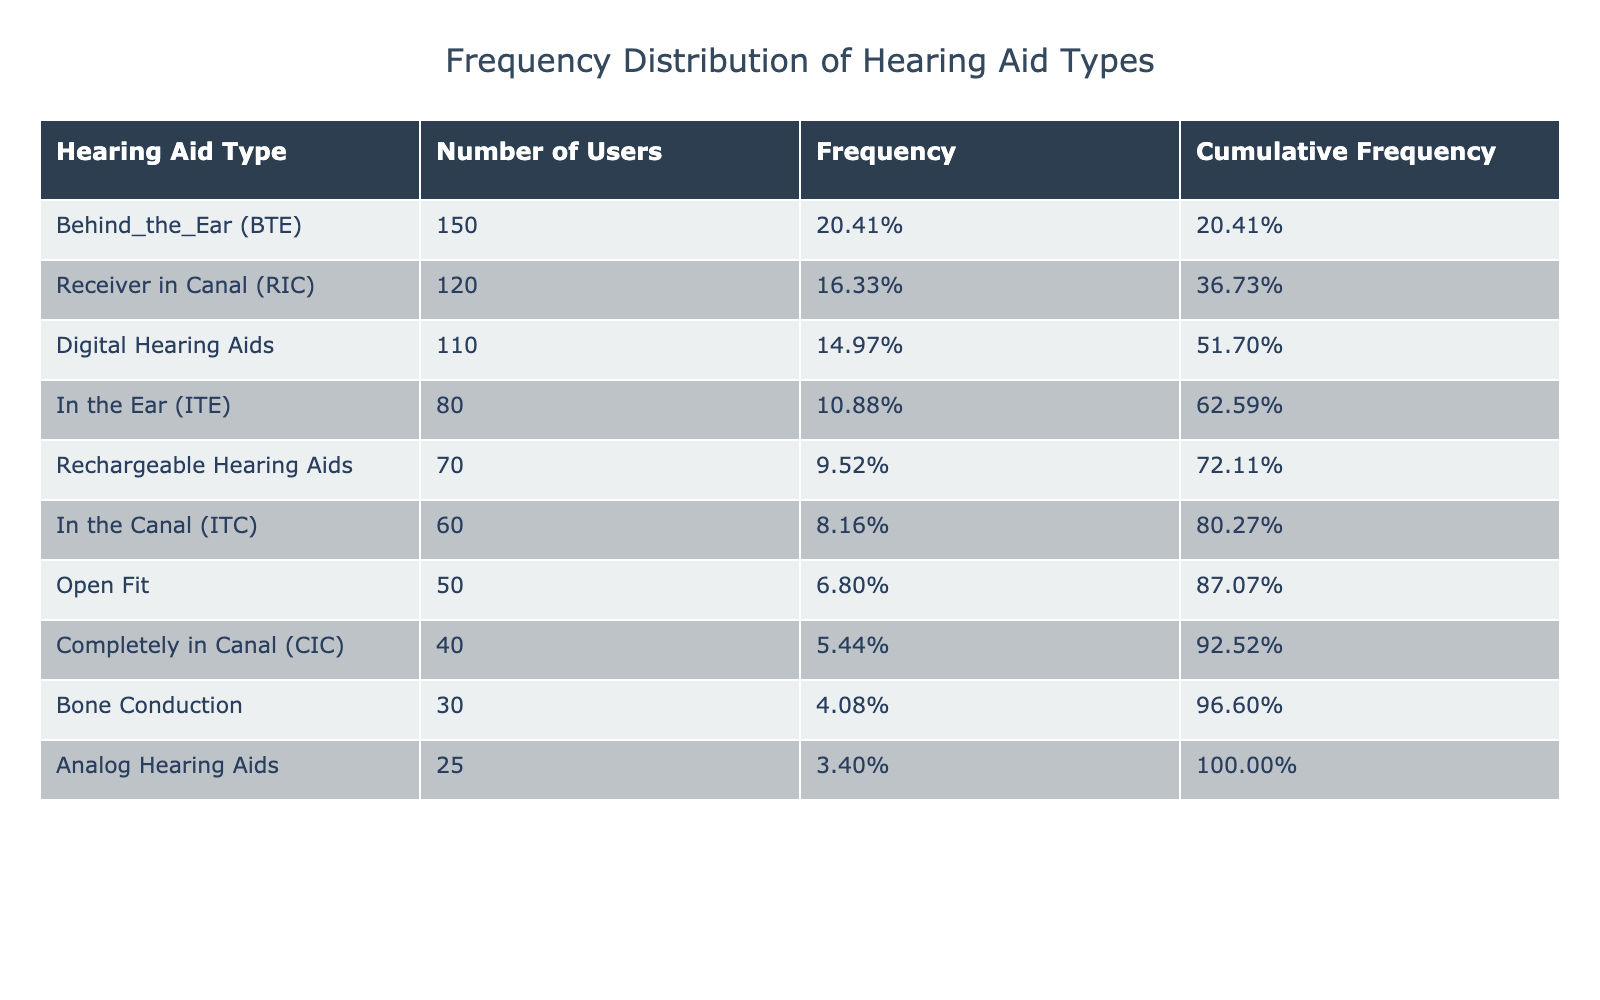What is the type of hearing aid with the highest number of users? The table shows the "Number of Users" for each hearing aid type and indicates that "Behind the Ear (BTE)" has 150 users, which is the highest figure in the table.
Answer: Behind the Ear (BTE) How many users are using Analog Hearing Aids? The table directly states that the number of users for "Analog Hearing Aids" is 25.
Answer: 25 What percentage of users use Bone Conduction aids? The total number of users across all hearing aid types is 750 (150 + 120 + 80 + 60 + 40 + 30 + 50 + 110 + 25 + 70). The number of Bone Conduction users is 30. Therefore, the percentage is (30/750) * 100 = 4%.
Answer: 4% What is the cumulative frequency of users for "In the Ear (ITE)"? To find the cumulative frequency for "In the Ear (ITE)", we add the frequencies of all types up to "In the Ear (ITE)". The frequencies are: BTE (20%), RIC (16%), ITE (10.67%). Thus, cumulative frequency = 20% + 16% + 10.67% = 46.67%.
Answer: 46.67% Are there more users of Rechargeable Hearing Aids than Completely in Canal (CIC) aids? The table shows that there are 70 users of Rechargeable Hearing Aids and 40 users of Completely in Canal (CIC) aids. Since 70 is greater than 40, the answer is yes.
Answer: Yes What is the difference in the number of users between the top two most used hearing aid types? The most used type is "Behind the Ear (BTE)" with 150 users, and the second most used is "Receiver in Canal (RIC)" with 120 users. The difference in users is calculated as 150 - 120 = 30.
Answer: 30 What fraction of the total users are using Digital Hearing Aids? The total number of users is 750, and the number of users for Digital Hearing Aids is 110. The fraction is calculated as 110/750 = 11/75 when simplified.
Answer: 11/75 Which type of hearing aids has fewer than 50 users? Looking at the table, "Completely in Canal (CIC)" with 40 users, "Bone Conduction" with 30 users, and "Analog Hearing Aids" with 25 users are the only types with fewer than 50 users.
Answer: Completely in Canal (CIC), Bone Conduction, Analog Hearing Aids 